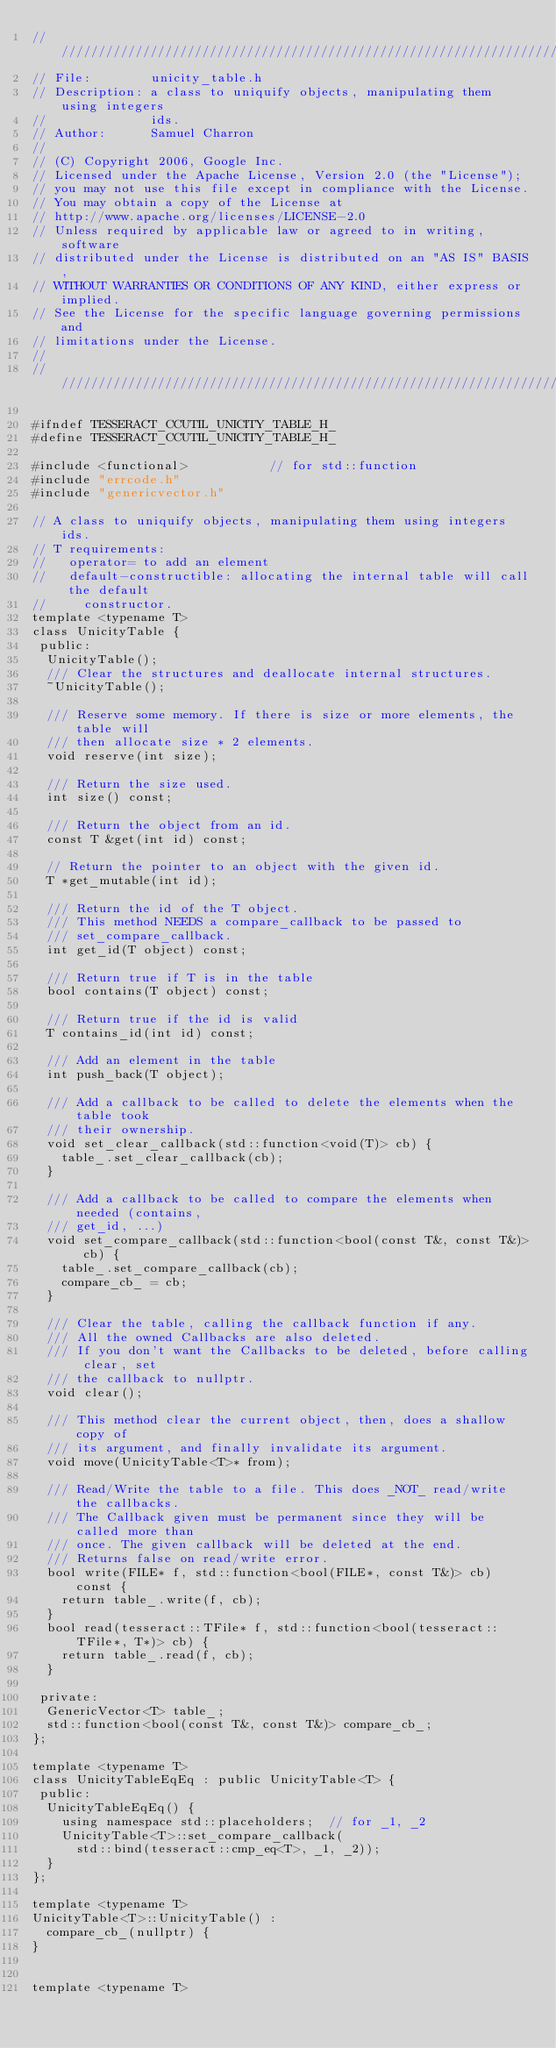<code> <loc_0><loc_0><loc_500><loc_500><_C_>///////////////////////////////////////////////////////////////////////
// File:        unicity_table.h
// Description: a class to uniquify objects, manipulating them using integers
//              ids.
// Author:      Samuel Charron
//
// (C) Copyright 2006, Google Inc.
// Licensed under the Apache License, Version 2.0 (the "License");
// you may not use this file except in compliance with the License.
// You may obtain a copy of the License at
// http://www.apache.org/licenses/LICENSE-2.0
// Unless required by applicable law or agreed to in writing, software
// distributed under the License is distributed on an "AS IS" BASIS,
// WITHOUT WARRANTIES OR CONDITIONS OF ANY KIND, either express or implied.
// See the License for the specific language governing permissions and
// limitations under the License.
//
///////////////////////////////////////////////////////////////////////

#ifndef TESSERACT_CCUTIL_UNICITY_TABLE_H_
#define TESSERACT_CCUTIL_UNICITY_TABLE_H_

#include <functional>           // for std::function
#include "errcode.h"
#include "genericvector.h"

// A class to uniquify objects, manipulating them using integers ids.
// T requirements:
//   operator= to add an element
//   default-constructible: allocating the internal table will call the default
//     constructor.
template <typename T>
class UnicityTable {
 public:
  UnicityTable();
  /// Clear the structures and deallocate internal structures.
  ~UnicityTable();

  /// Reserve some memory. If there is size or more elements, the table will
  /// then allocate size * 2 elements.
  void reserve(int size);

  /// Return the size used.
  int size() const;

  /// Return the object from an id.
  const T &get(int id) const;

  // Return the pointer to an object with the given id.
  T *get_mutable(int id);

  /// Return the id of the T object.
  /// This method NEEDS a compare_callback to be passed to
  /// set_compare_callback.
  int get_id(T object) const;

  /// Return true if T is in the table
  bool contains(T object) const;

  /// Return true if the id is valid
  T contains_id(int id) const;

  /// Add an element in the table
  int push_back(T object);

  /// Add a callback to be called to delete the elements when the table took
  /// their ownership.
  void set_clear_callback(std::function<void(T)> cb) {
    table_.set_clear_callback(cb);
  }

  /// Add a callback to be called to compare the elements when needed (contains,
  /// get_id, ...)
  void set_compare_callback(std::function<bool(const T&, const T&)> cb) {
    table_.set_compare_callback(cb);
    compare_cb_ = cb;
  }

  /// Clear the table, calling the callback function if any.
  /// All the owned Callbacks are also deleted.
  /// If you don't want the Callbacks to be deleted, before calling clear, set
  /// the callback to nullptr.
  void clear();

  /// This method clear the current object, then, does a shallow copy of
  /// its argument, and finally invalidate its argument.
  void move(UnicityTable<T>* from);

  /// Read/Write the table to a file. This does _NOT_ read/write the callbacks.
  /// The Callback given must be permanent since they will be called more than
  /// once. The given callback will be deleted at the end.
  /// Returns false on read/write error.
  bool write(FILE* f, std::function<bool(FILE*, const T&)> cb) const {
    return table_.write(f, cb);
  }
  bool read(tesseract::TFile* f, std::function<bool(tesseract::TFile*, T*)> cb) {
    return table_.read(f, cb);
  }

 private:
  GenericVector<T> table_;
  std::function<bool(const T&, const T&)> compare_cb_;
};

template <typename T>
class UnicityTableEqEq : public UnicityTable<T> {
 public:
  UnicityTableEqEq() {
    using namespace std::placeholders;  // for _1, _2
    UnicityTable<T>::set_compare_callback(
      std::bind(tesseract::cmp_eq<T>, _1, _2));
  }
};

template <typename T>
UnicityTable<T>::UnicityTable() :
  compare_cb_(nullptr) {
}


template <typename T></code> 